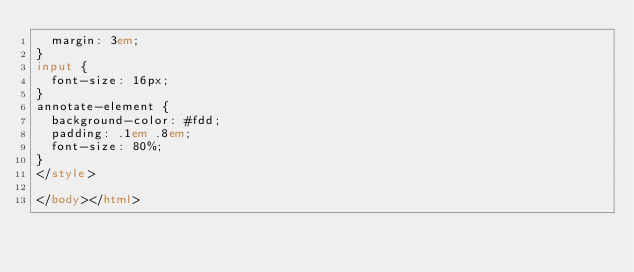Convert code to text. <code><loc_0><loc_0><loc_500><loc_500><_HTML_>  margin: 3em;
}
input {
  font-size: 16px;
}
annotate-element {
  background-color: #fdd;
  padding: .1em .8em;
  font-size: 80%;
}
</style>

</body></html>
</code> 